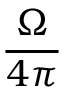<formula> <loc_0><loc_0><loc_500><loc_500>\frac { \Omega } { 4 \pi }</formula> 